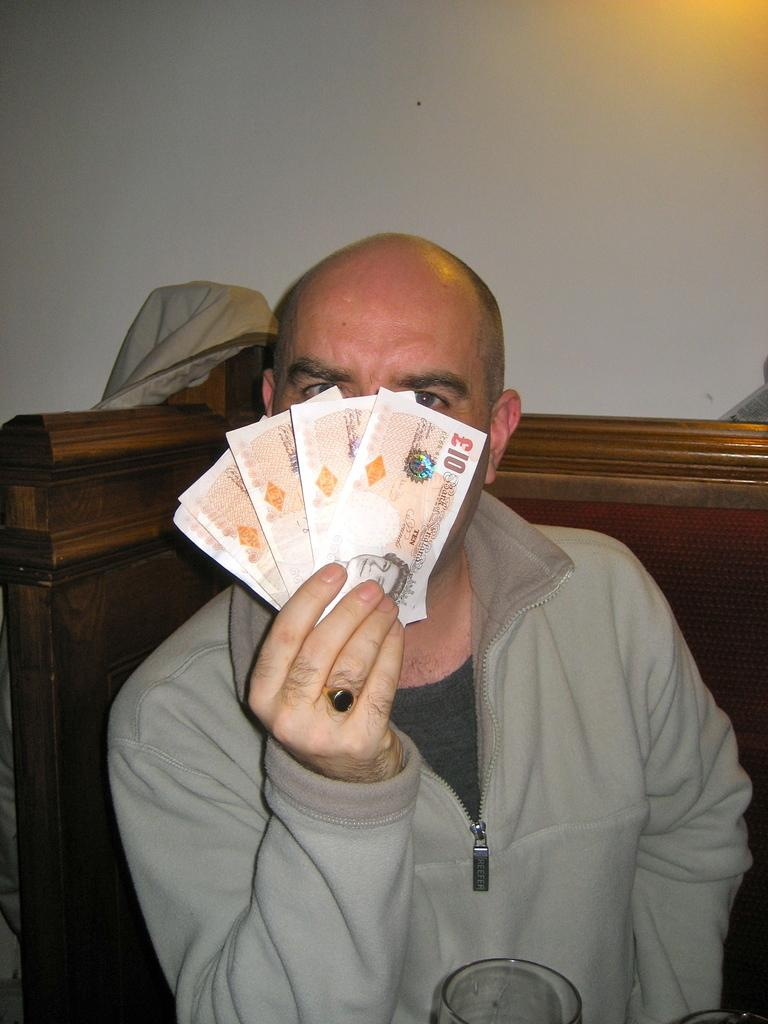Who or what is the main subject in the image? There is a person in the center of the image. What is the person holding in the image? The person is holding a currency. What can be seen in the background of the image? There is a wall and cloth in the background of the image. Are there any buttons visible on the person's clothing in the image? There is no information about buttons on the person's clothing in the provided facts. Can you see a goat in the image? There is no mention of a goat in the provided facts, so it cannot be determined if one is present in the image. 